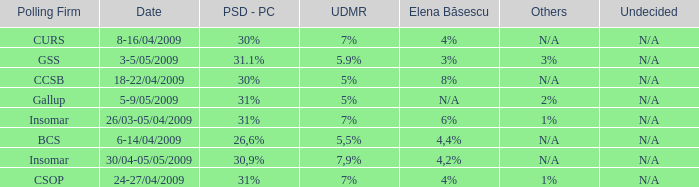What date has the others of 2%? 5-9/05/2009. 